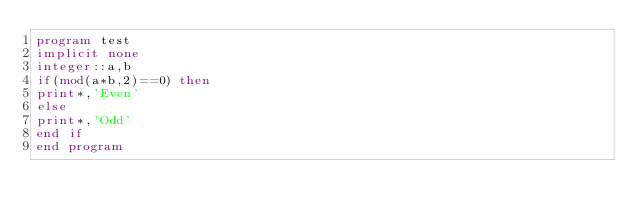Convert code to text. <code><loc_0><loc_0><loc_500><loc_500><_FORTRAN_>program test
implicit none
integer::a,b
if(mod(a*b,2)==0) then 
print*,'Even'
else 
print*,'Odd'
end if
end program</code> 